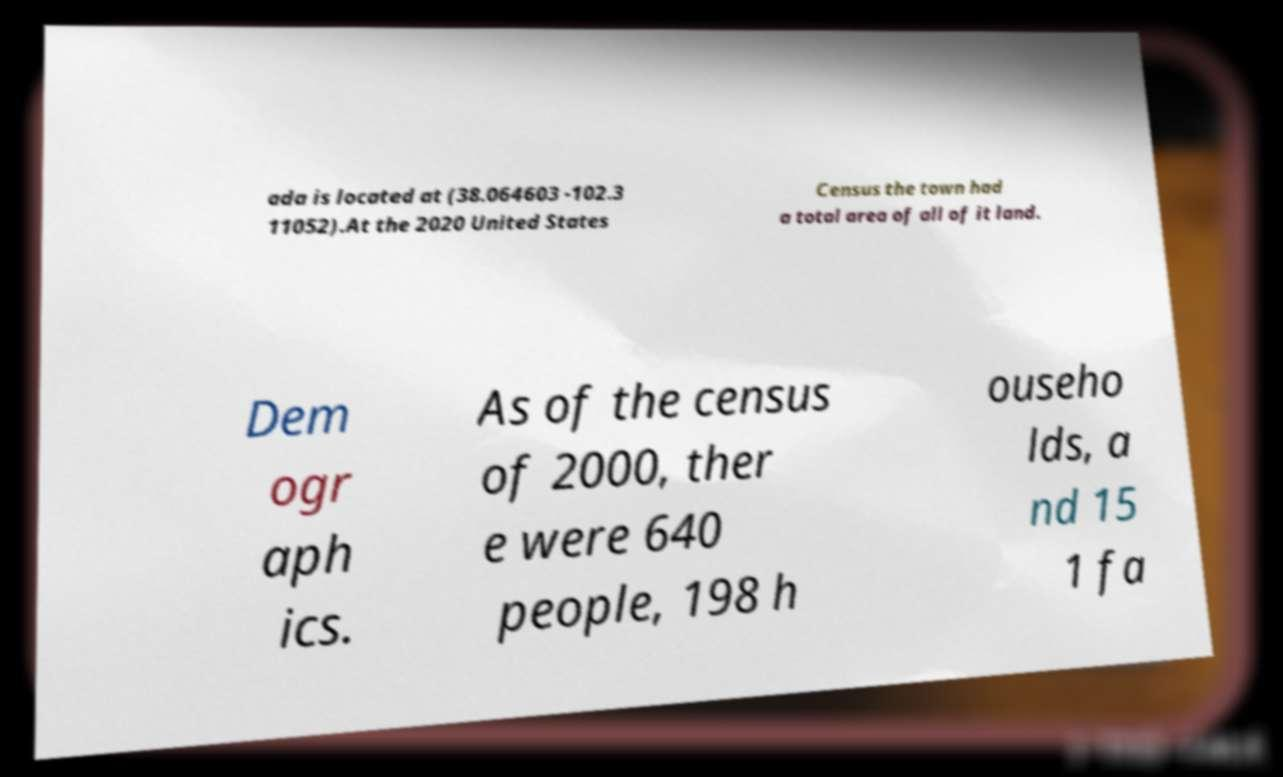What messages or text are displayed in this image? I need them in a readable, typed format. ada is located at (38.064603 -102.3 11052).At the 2020 United States Census the town had a total area of all of it land. Dem ogr aph ics. As of the census of 2000, ther e were 640 people, 198 h ouseho lds, a nd 15 1 fa 